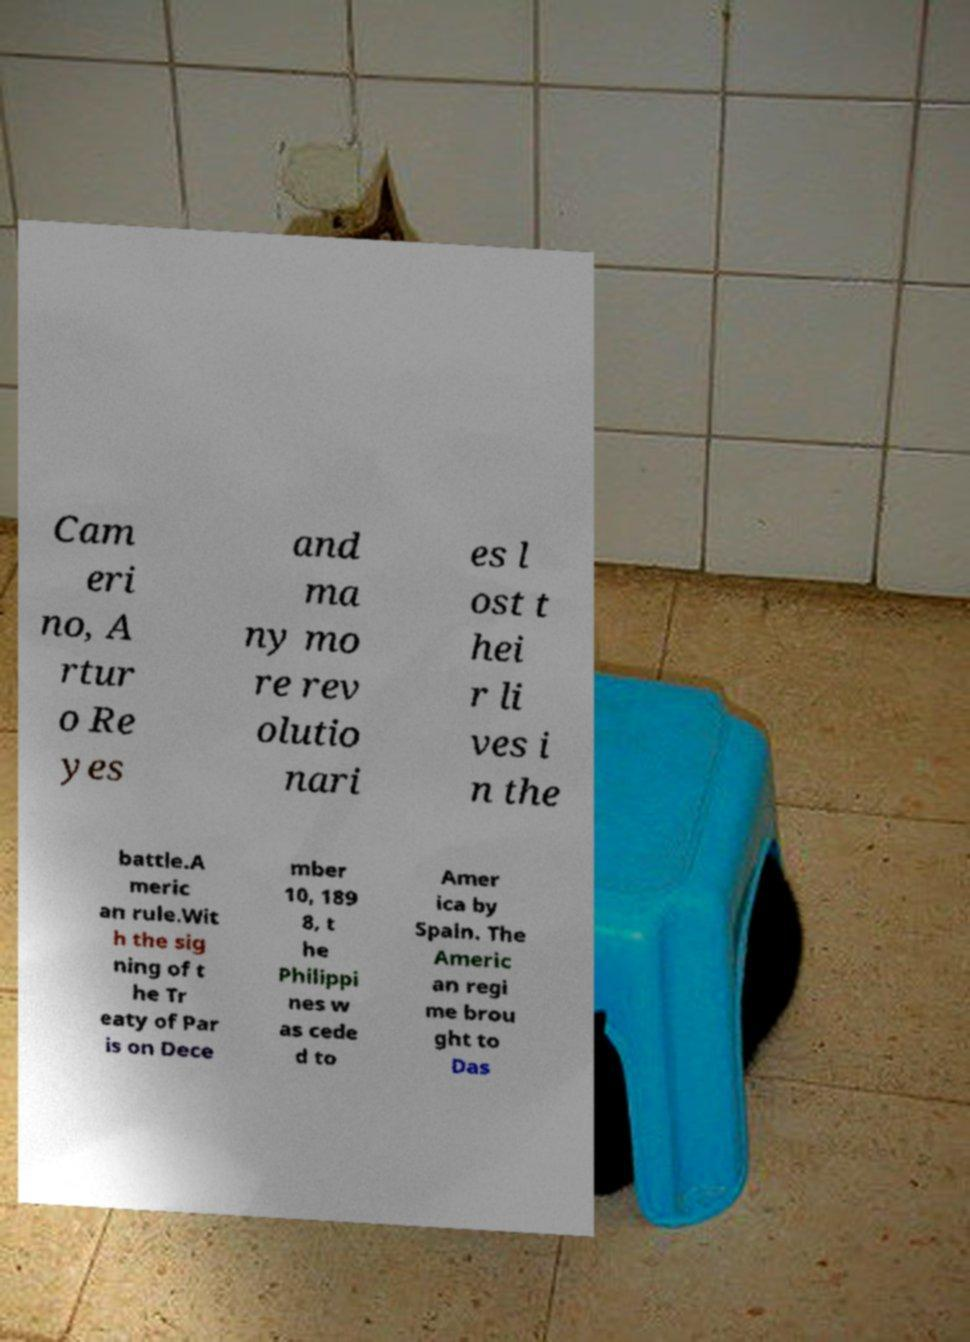Can you read and provide the text displayed in the image?This photo seems to have some interesting text. Can you extract and type it out for me? Cam eri no, A rtur o Re yes and ma ny mo re rev olutio nari es l ost t hei r li ves i n the battle.A meric an rule.Wit h the sig ning of t he Tr eaty of Par is on Dece mber 10, 189 8, t he Philippi nes w as cede d to Amer ica by Spain. The Americ an regi me brou ght to Das 